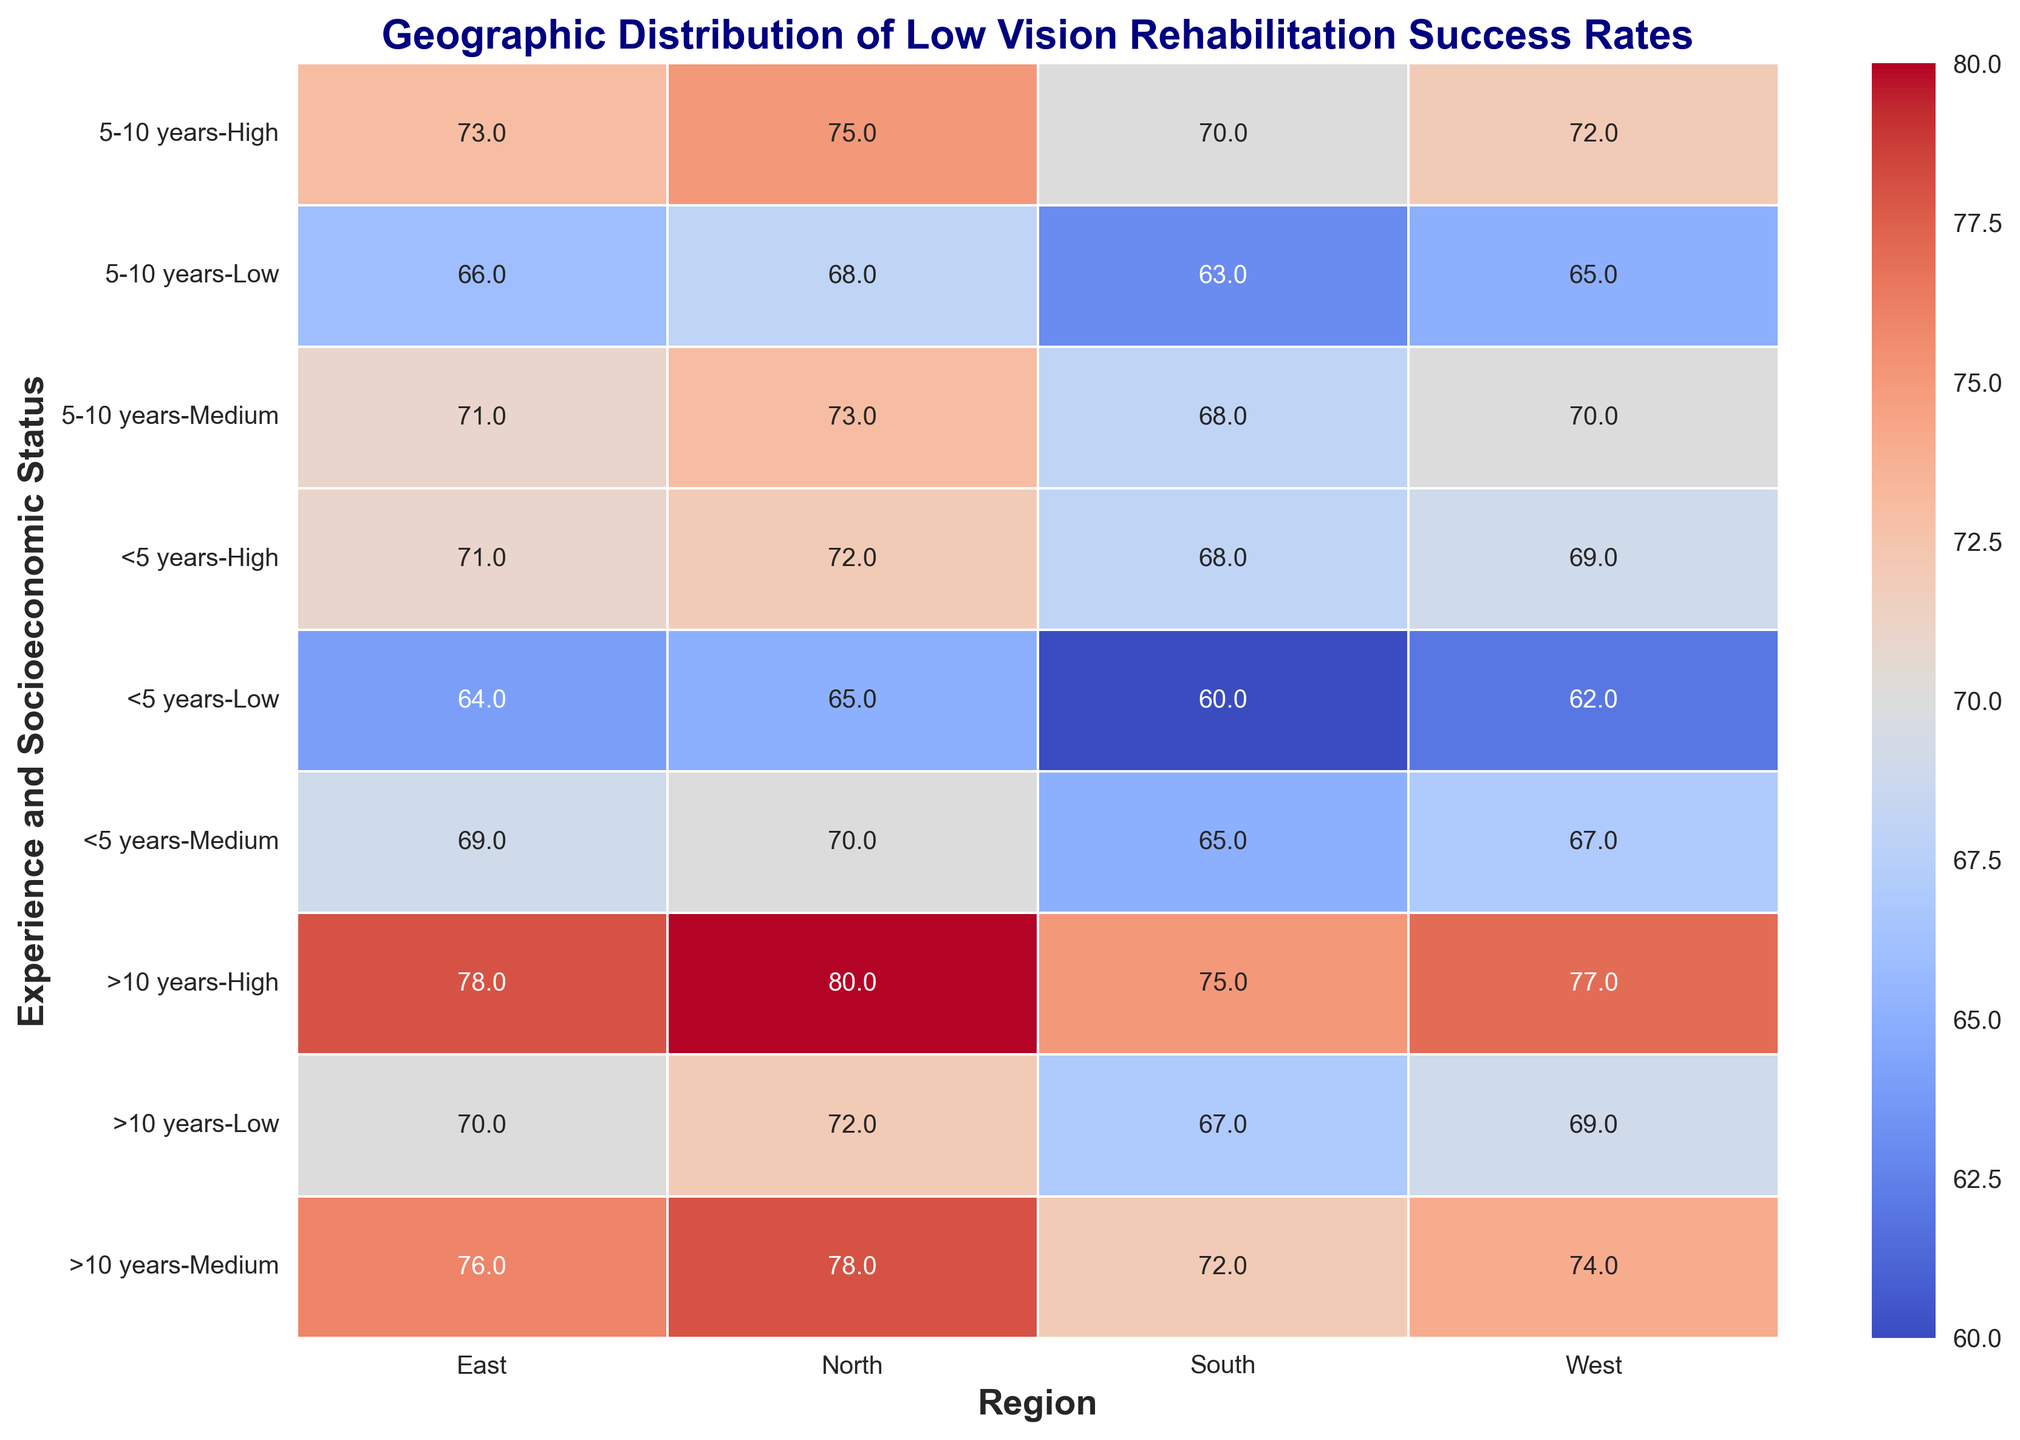What is the average Low Vision Rehabilitation Success Rate for optometrists with less than 5 years of experience across all regions and socioeconomic statuses? To find this average, add all the success rates for <5 years across all regions (65, 70, 72, 60, 65, 68, 64, 69, 71, 62, 67, 69) and divide by the total number of data points, which is 12. The total sum is 802, so the average is 802 / 12.
Answer: 66.8 Which region has the highest Low Vision Rehabilitation Success Rate for patients with high socioeconomic status and optometrists with more than 10 years of experience? Look at the row for >10 years experience and high socioeconomic status. Check the values for North (80), South (75), East (78), and West (77). The maximum value is in the North region.
Answer: North Compare the Low Vision Rehabilitation Success Rates between optometrists with 5-10 years of experience and greater than 10 years of experience in the West region for medium socioeconomic status patients. Which group performs better? For the West region with medium SES, look at the success rates for 5-10 years experience (70) and >10 years experience (74). The rate for >10 years experience is higher.
Answer: >10 years What is the difference in Low Vision Rehabilitation Success Rates between the North and South regions for patients with low socioeconomic status and optometrists with 5-10 years of experience? Look at the values for the North (68) and South (63) regions for 5-10 years experience and low SES. Subtract the South rate from the North rate: 68 - 63 = 5.
Answer: 5 How does the color intensity vary for the East region's success rates between patients with low socioeconomic status for optometrists with less than 5 years, 5-10 years, and more than 10 years of experience? Compare the shades of the cells in the East region for low SES. Less than 5 years is 64 (lighter), 5-10 years is 66 (slightly darker), and >10 years is 70 (even darker). The intensity increases with experience.
Answer: The intensity increases with experience What is the average Low Vision Rehabilitation Success Rate across all regions for high socioeconomic status patients? Add all the rates for high SES across all regions and experiences (72, 68, 71, 69, 75, 70, 73, 72, 80, 75, 78, 77), then divide by 12. The sum is 870, so the average is 870 / 12.
Answer: 72.5 In which region do optometrists with less than 5 years of experience achieve the lowest Low Vision Rehabilitation Success Rate for medium socioeconomic status patients? For <5 years experience and medium SES, compare the rates in North (70), South (65), East (69), and West (67). The South region has the lowest rate.
Answer: South What trend do you observe regarding the Low Vision Rehabilitation Success Rates as optometrists' years of experience increase in the East region for all socioeconomic statuses? Look at the East region across different experience levels. For low SES: 64, 66, 70; for medium SES: 69, 71, 76; for high SES: 71, 73, 78. The trend is that success rates increase with more years of experience.
Answer: Success rates increase with experience 